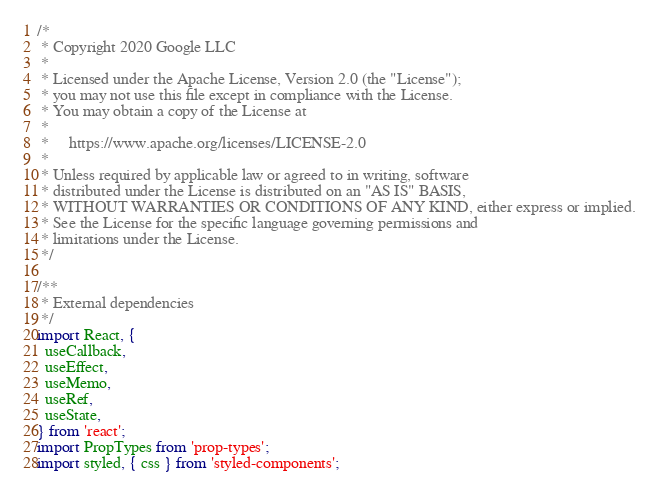Convert code to text. <code><loc_0><loc_0><loc_500><loc_500><_JavaScript_>/*
 * Copyright 2020 Google LLC
 *
 * Licensed under the Apache License, Version 2.0 (the "License");
 * you may not use this file except in compliance with the License.
 * You may obtain a copy of the License at
 *
 *     https://www.apache.org/licenses/LICENSE-2.0
 *
 * Unless required by applicable law or agreed to in writing, software
 * distributed under the License is distributed on an "AS IS" BASIS,
 * WITHOUT WARRANTIES OR CONDITIONS OF ANY KIND, either express or implied.
 * See the License for the specific language governing permissions and
 * limitations under the License.
 */

/**
 * External dependencies
 */
import React, {
  useCallback,
  useEffect,
  useMemo,
  useRef,
  useState,
} from 'react';
import PropTypes from 'prop-types';
import styled, { css } from 'styled-components';</code> 